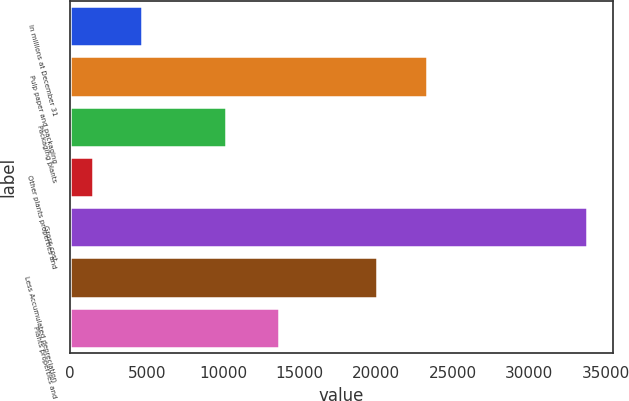<chart> <loc_0><loc_0><loc_500><loc_500><bar_chart><fcel>In millions at December 31<fcel>Pulp paper and packaging<fcel>Packaging plants<fcel>Other plants properties and<fcel>Gross cost<fcel>Less Accumulated depreciation<fcel>Plants properties and<nl><fcel>4704.8<fcel>23300.8<fcel>10163<fcel>1478<fcel>33746<fcel>20074<fcel>13672<nl></chart> 